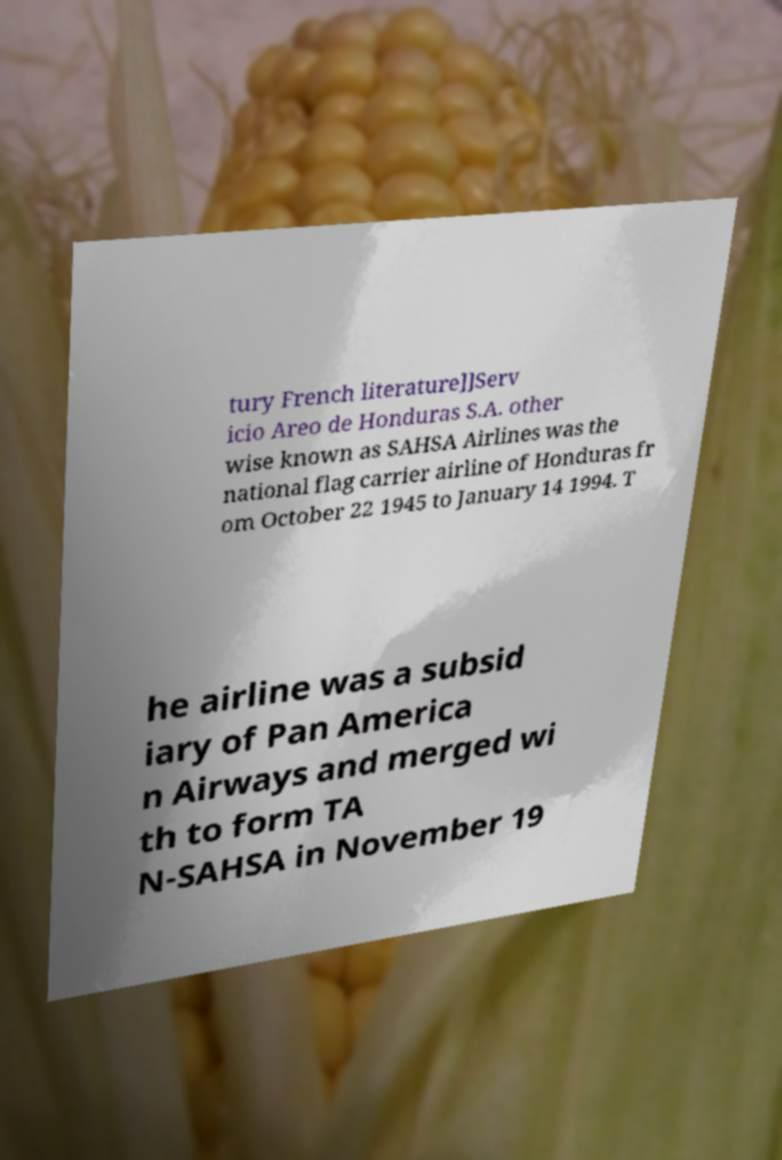Could you extract and type out the text from this image? tury French literature]]Serv icio Areo de Honduras S.A. other wise known as SAHSA Airlines was the national flag carrier airline of Honduras fr om October 22 1945 to January 14 1994. T he airline was a subsid iary of Pan America n Airways and merged wi th to form TA N-SAHSA in November 19 